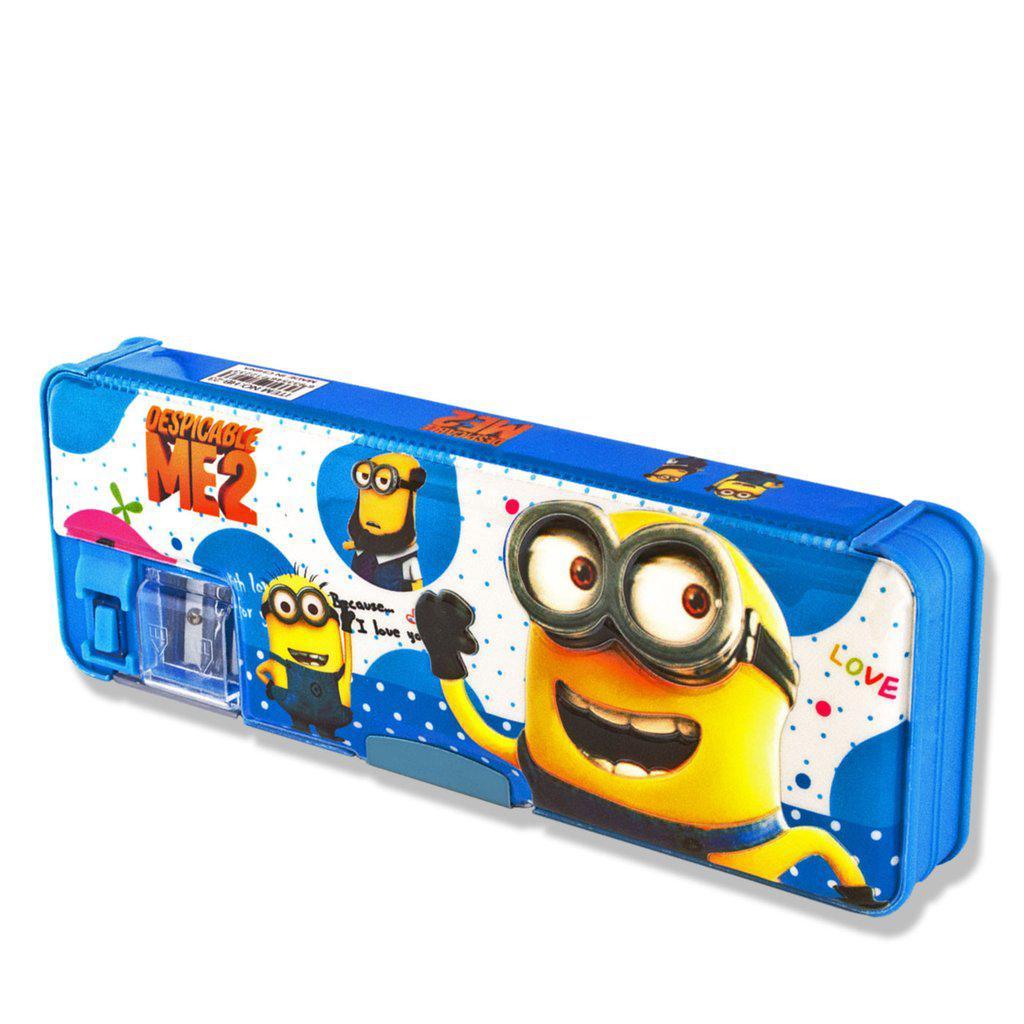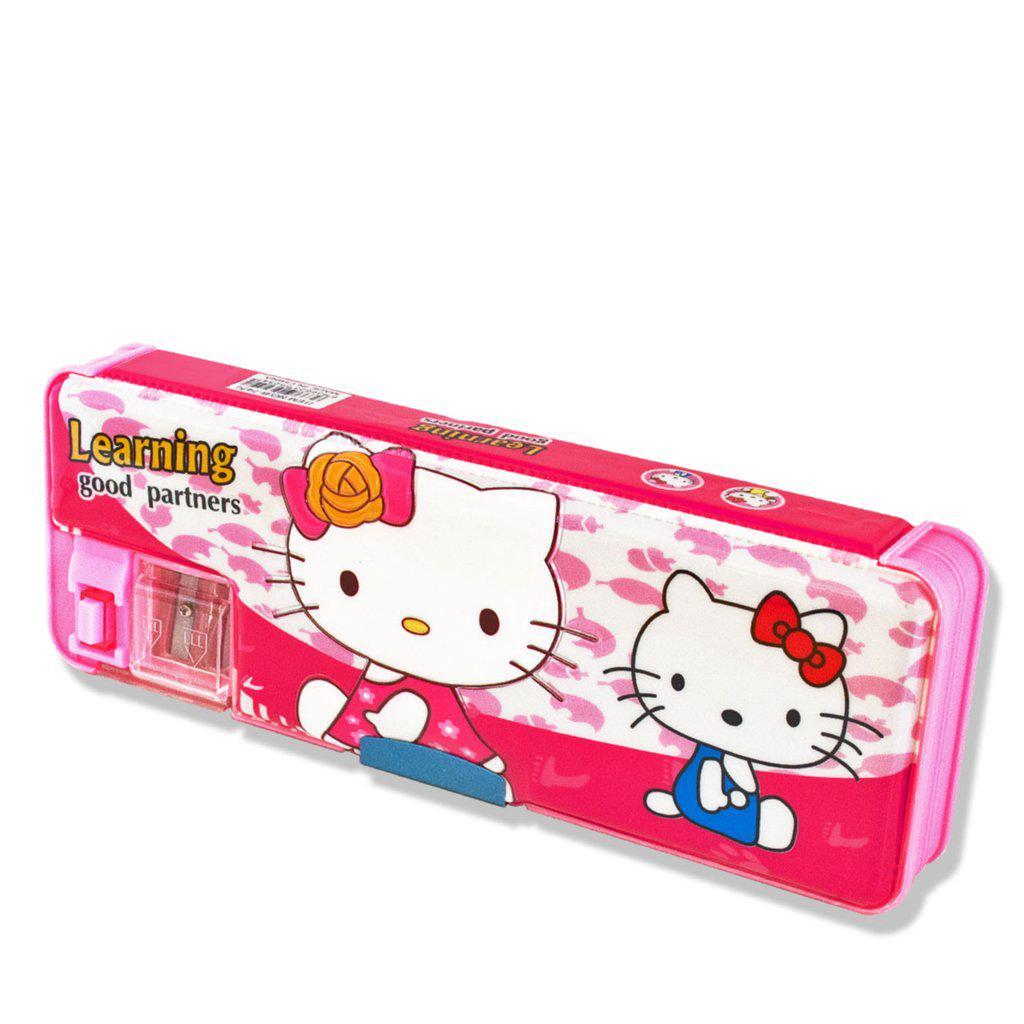The first image is the image on the left, the second image is the image on the right. Evaluate the accuracy of this statement regarding the images: "There is at most two pencil holders.". Is it true? Answer yes or no. Yes. The first image is the image on the left, the second image is the image on the right. For the images shown, is this caption "At least one image shows a pencil case decorated with an animated scene inspired by a kids' movie." true? Answer yes or no. Yes. 